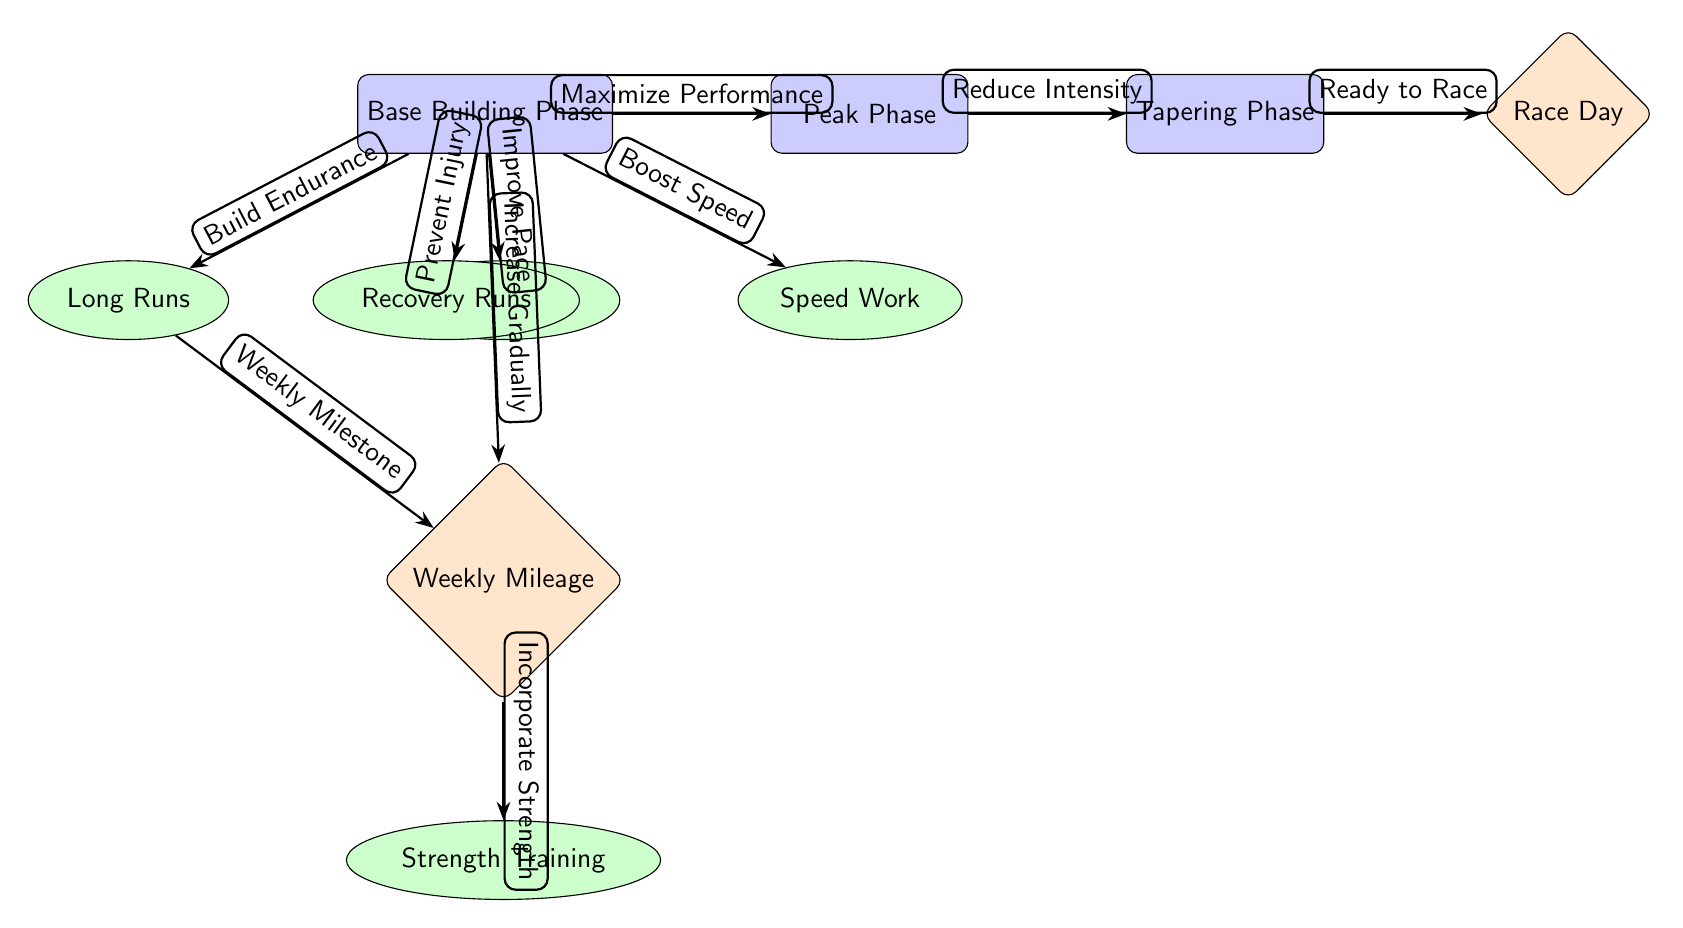What is the title of the first phase? The first phase in the diagram is labeled as "Base Building Phase," which is the starting point for the training plan.
Answer: Base Building Phase How many workout types are listed in the Base Building Phase? In the Base Building Phase, there are five workout types leading out, which are Long Runs, Speed Work, Tempo Runs, Recovery Runs, and the connection to Weekly Mileage.
Answer: Five Which workout type is aimed at "Boost Speed"? The "Boost Speed" connection refers specifically to the workout type labeled "Speed Work." This means this workout is focused on increasing running speed.
Answer: Speed Work What is the goal of the Weekly Mileage node? The Weekly Mileage node is associated with the goal of incorporating strength training into the overall training plan, indicating the importance of mileage to the training process.
Answer: Incorporate Strength Which phase comes after Peak Phase? Following the Peak Phase, the diagram indicates the Tapering Phase, which suggests a reduction in training intensity leading up to the race.
Answer: Tapering Phase What relationship is described between Long Runs and Weekly Mileage? The diagram illustrates that Long Runs contribute to achieving a "Weekly Milestone," showcasing their importance in reaching the overall weekly mileage goal.
Answer: Weekly Milestone How does the Base Building Phase influence the Peak Phase? The Base Building Phase specifies maximizing performance as a factor that leads into the Peak Phase, indicating its foundational role in the training schedule.
Answer: Maximize Performance What type of edge connects the Tapering Phase to Race Day? The edge connecting the Tapering Phase to Race Day is labeled "Ready to Race," indicating that the tapering process prepares runners for optimal performance on race day.
Answer: Ready to Race 